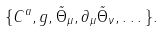Convert formula to latex. <formula><loc_0><loc_0><loc_500><loc_500>\{ C ^ { a } , g , \tilde { \Theta } _ { \mu } , \partial _ { \mu } \tilde { \Theta } _ { \nu } , \dots \} .</formula> 